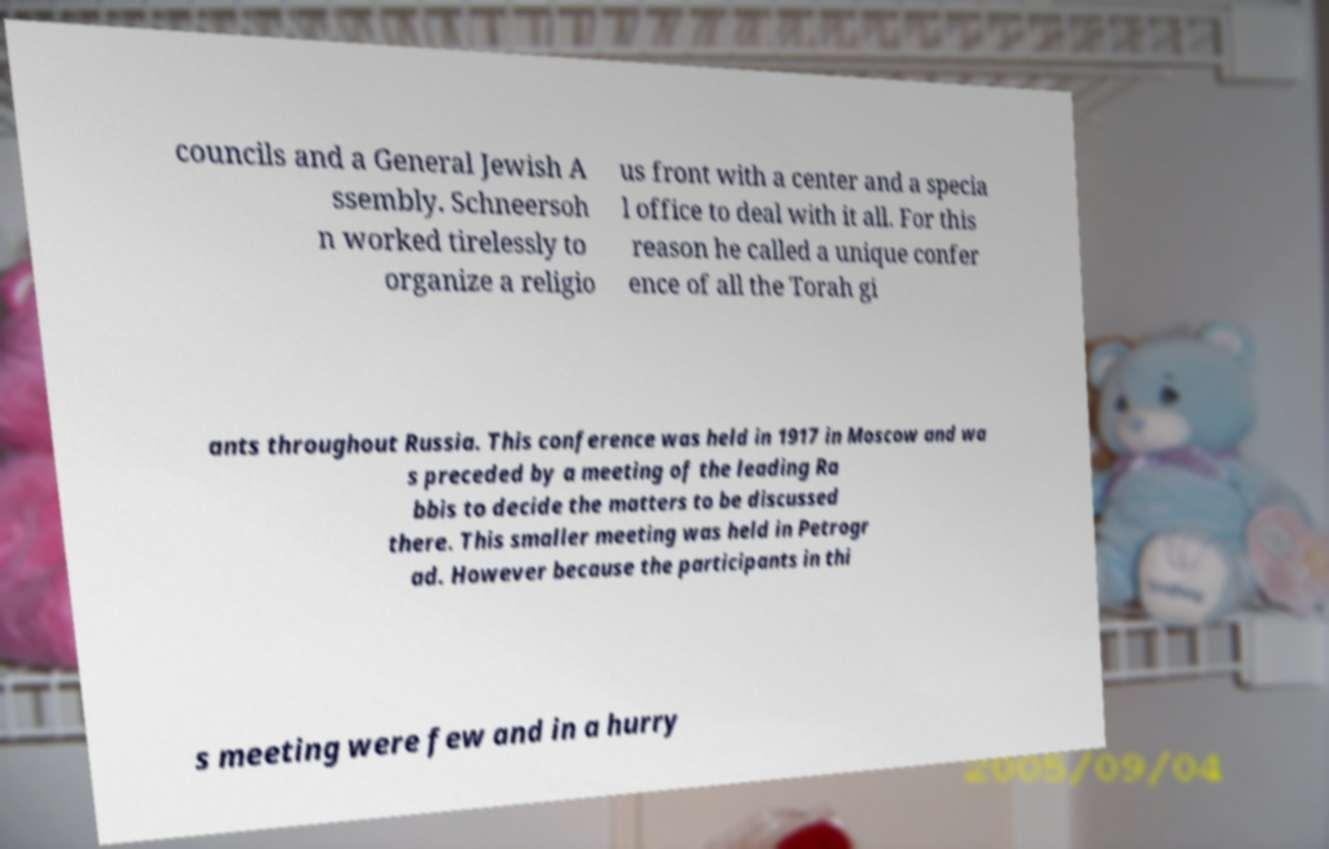Please identify and transcribe the text found in this image. councils and a General Jewish A ssembly. Schneersoh n worked tirelessly to organize a religio us front with a center and a specia l office to deal with it all. For this reason he called a unique confer ence of all the Torah gi ants throughout Russia. This conference was held in 1917 in Moscow and wa s preceded by a meeting of the leading Ra bbis to decide the matters to be discussed there. This smaller meeting was held in Petrogr ad. However because the participants in thi s meeting were few and in a hurry 